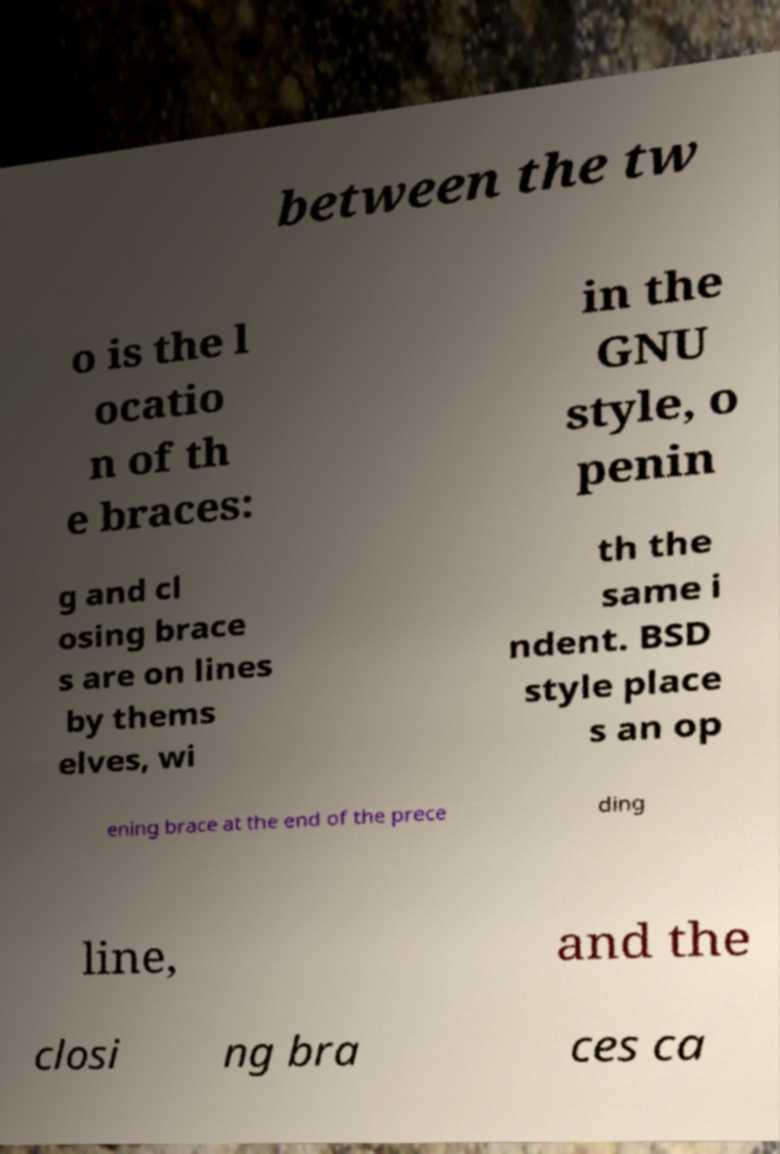Please read and relay the text visible in this image. What does it say? between the tw o is the l ocatio n of th e braces: in the GNU style, o penin g and cl osing brace s are on lines by thems elves, wi th the same i ndent. BSD style place s an op ening brace at the end of the prece ding line, and the closi ng bra ces ca 